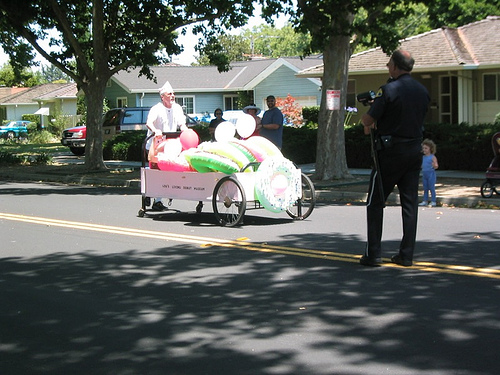<image>
Is the tree above the vendor? Yes. The tree is positioned above the vendor in the vertical space, higher up in the scene. 